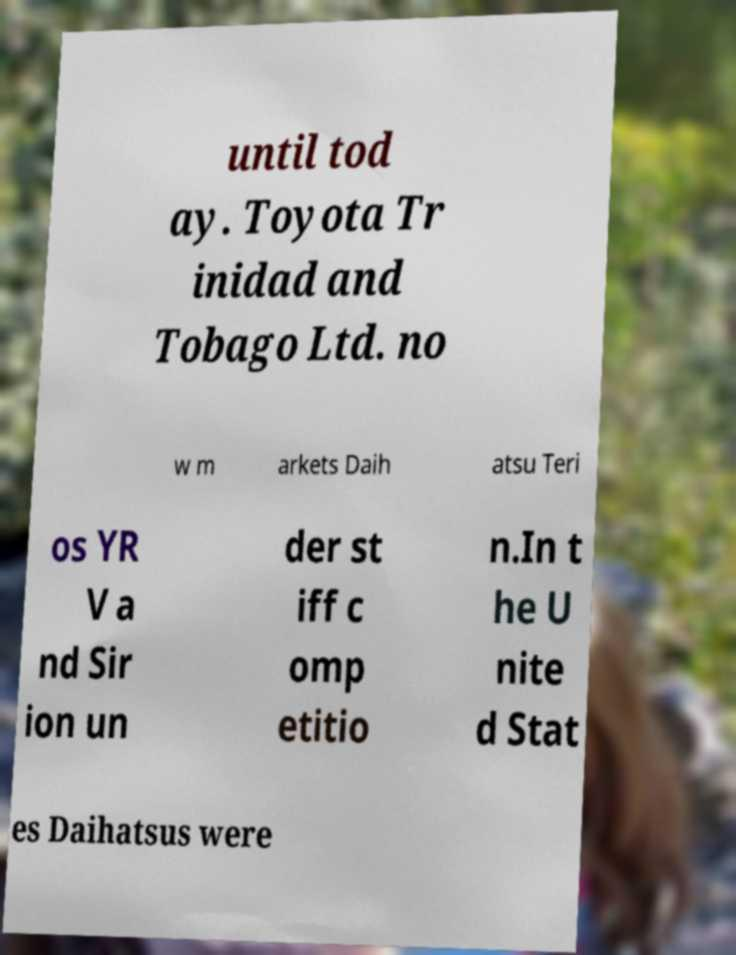Can you read and provide the text displayed in the image?This photo seems to have some interesting text. Can you extract and type it out for me? until tod ay. Toyota Tr inidad and Tobago Ltd. no w m arkets Daih atsu Teri os YR V a nd Sir ion un der st iff c omp etitio n.In t he U nite d Stat es Daihatsus were 